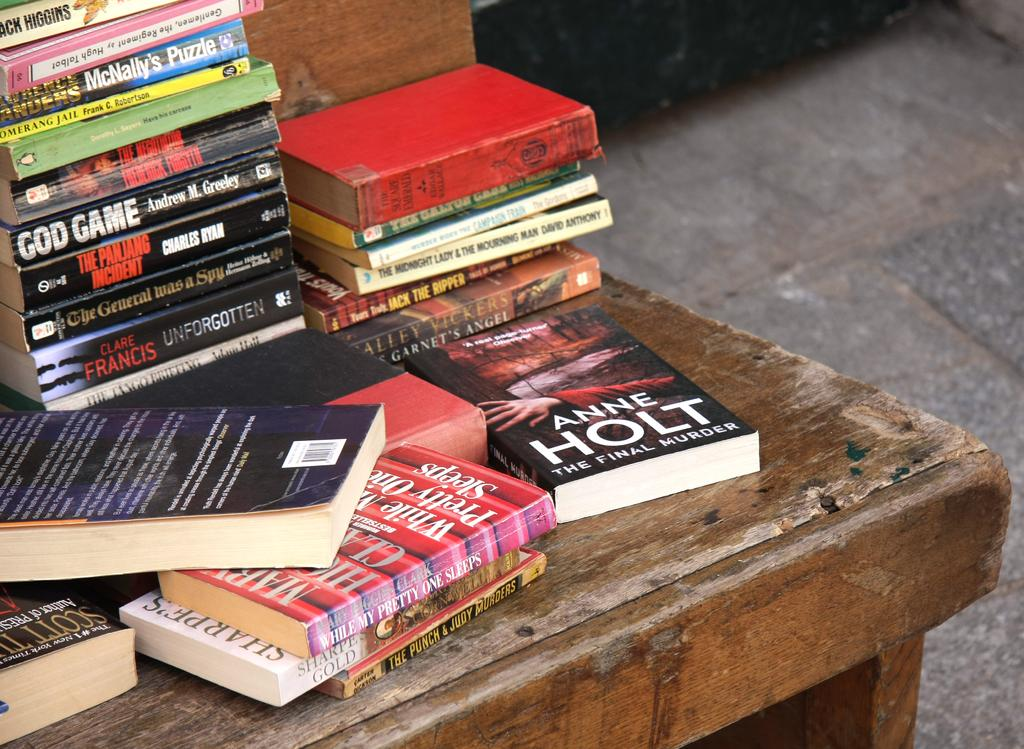What objects are present in the image? There are books in the image. Where are the books placed? The books are kept on a wooden table. What type of surface is visible beneath the table? There is a floor visible in the image. Who is the owner of the books in the image? The image does not provide information about the owner of the books. What suggestion can be made to improve the organization of the books in the image? The image does not provide enough information to make a suggestion about organizing the books. 